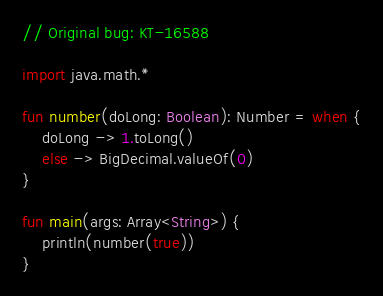Convert code to text. <code><loc_0><loc_0><loc_500><loc_500><_Kotlin_>// Original bug: KT-16588

import java.math.*

fun number(doLong: Boolean): Number = when {
    doLong -> 1.toLong()
    else -> BigDecimal.valueOf(0)
}

fun main(args: Array<String>) {
    println(number(true))
}
</code> 